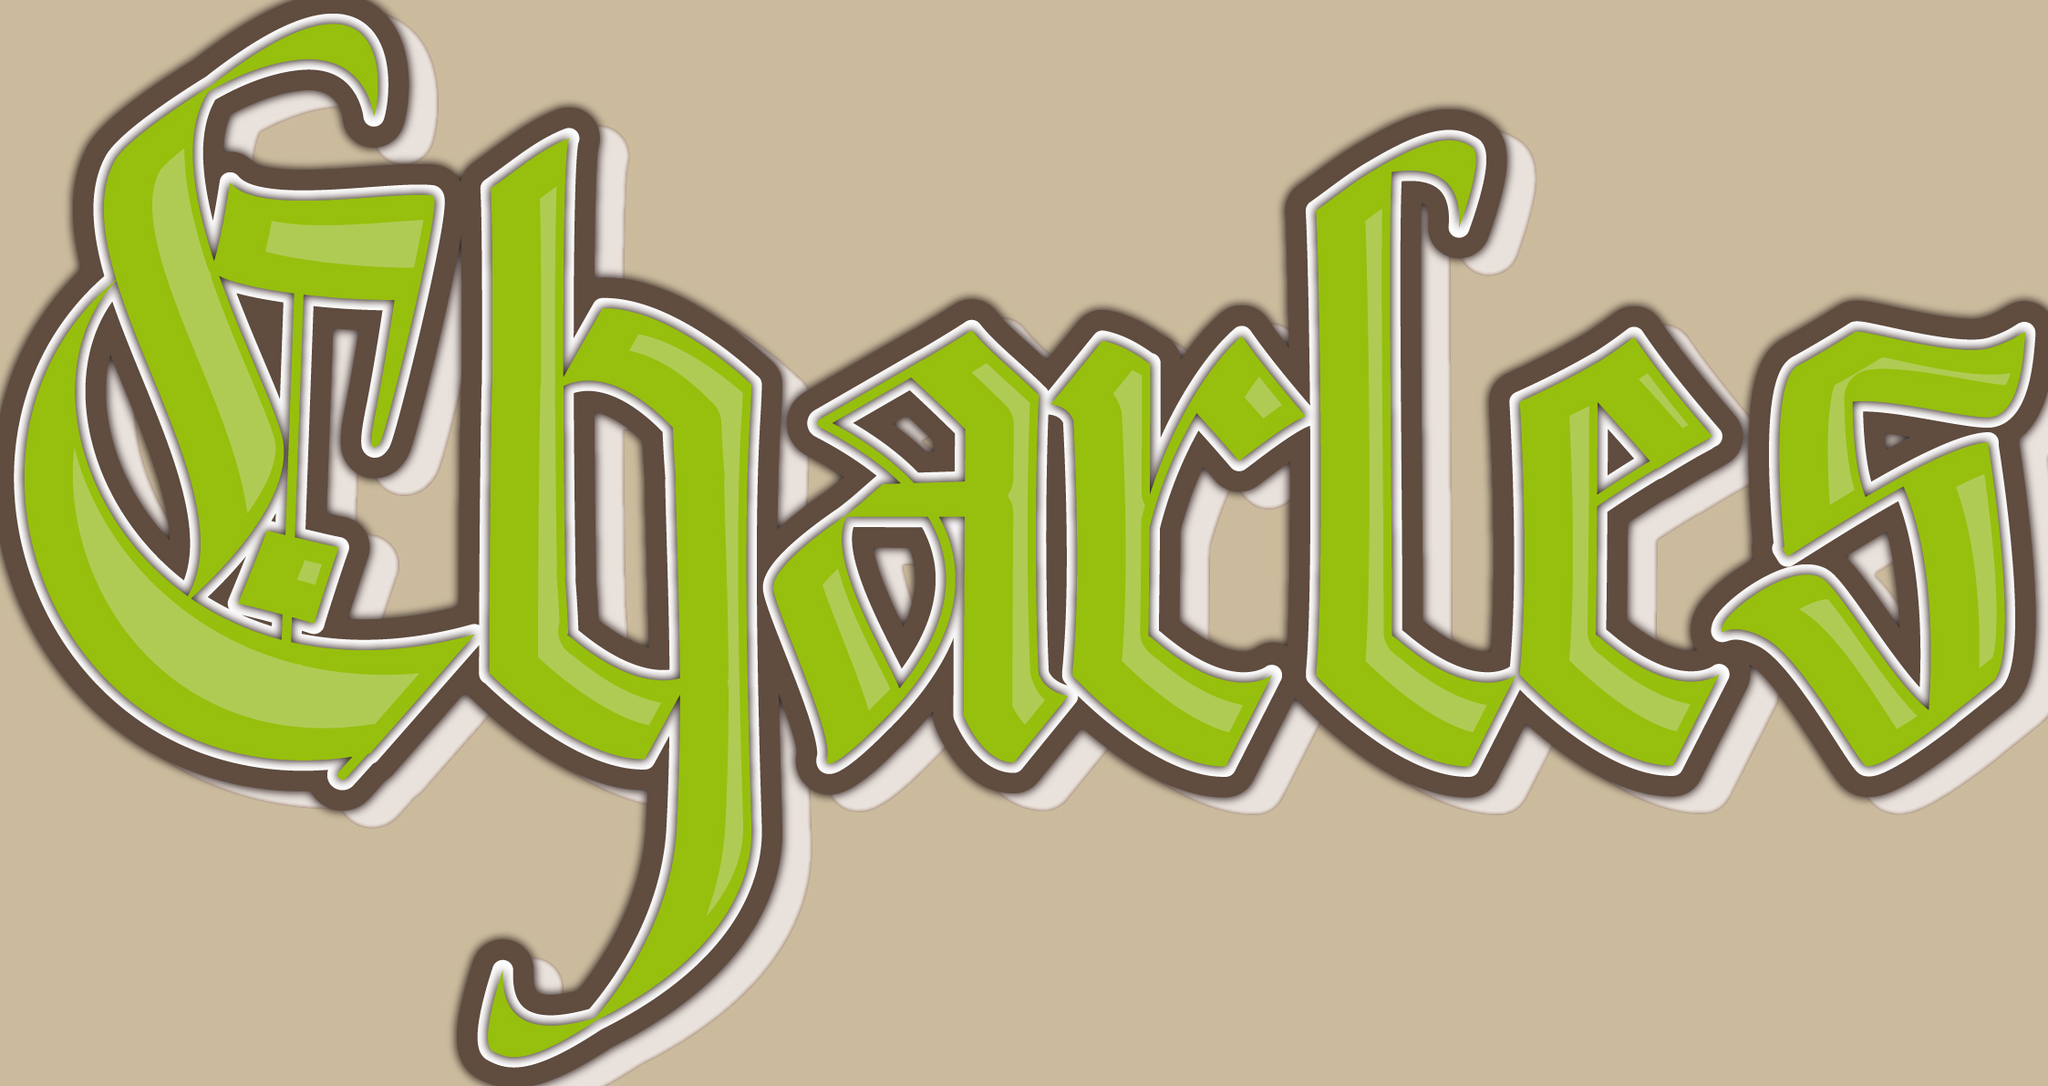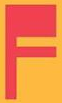What words are shown in these images in order, separated by a semicolon? Charles; F 